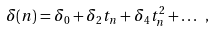<formula> <loc_0><loc_0><loc_500><loc_500>\delta ( n ) = \delta _ { 0 } + \delta _ { 2 } t _ { n } + \delta _ { 4 } t _ { n } ^ { 2 } + \dots \ ,</formula> 